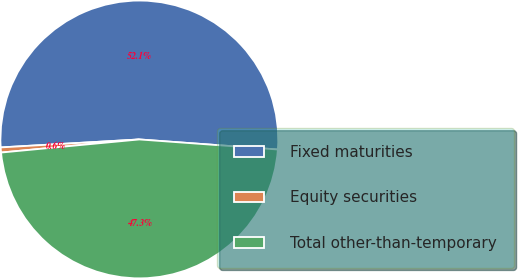Convert chart to OTSL. <chart><loc_0><loc_0><loc_500><loc_500><pie_chart><fcel>Fixed maturities<fcel>Equity securities<fcel>Total other-than-temporary<nl><fcel>52.07%<fcel>0.59%<fcel>47.34%<nl></chart> 